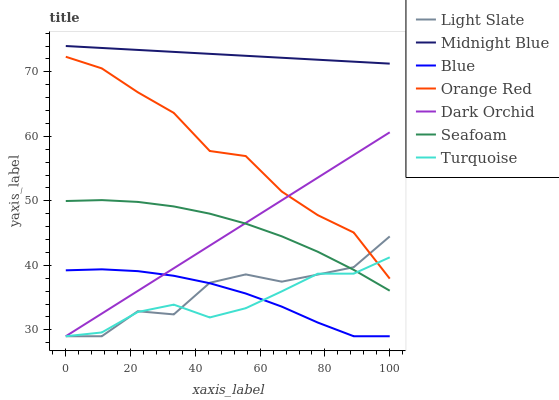Does Turquoise have the minimum area under the curve?
Answer yes or no. Yes. Does Midnight Blue have the maximum area under the curve?
Answer yes or no. Yes. Does Midnight Blue have the minimum area under the curve?
Answer yes or no. No. Does Turquoise have the maximum area under the curve?
Answer yes or no. No. Is Midnight Blue the smoothest?
Answer yes or no. Yes. Is Light Slate the roughest?
Answer yes or no. Yes. Is Turquoise the smoothest?
Answer yes or no. No. Is Turquoise the roughest?
Answer yes or no. No. Does Blue have the lowest value?
Answer yes or no. Yes. Does Midnight Blue have the lowest value?
Answer yes or no. No. Does Midnight Blue have the highest value?
Answer yes or no. Yes. Does Turquoise have the highest value?
Answer yes or no. No. Is Blue less than Seafoam?
Answer yes or no. Yes. Is Orange Red greater than Seafoam?
Answer yes or no. Yes. Does Turquoise intersect Blue?
Answer yes or no. Yes. Is Turquoise less than Blue?
Answer yes or no. No. Is Turquoise greater than Blue?
Answer yes or no. No. Does Blue intersect Seafoam?
Answer yes or no. No. 